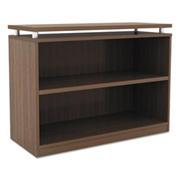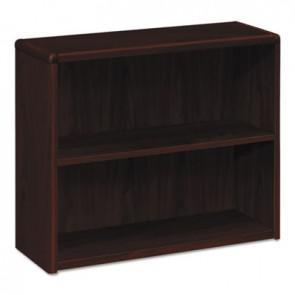The first image is the image on the left, the second image is the image on the right. Analyze the images presented: Is the assertion "The left and right image contains the same number shelves facing opposite ways." valid? Answer yes or no. No. 